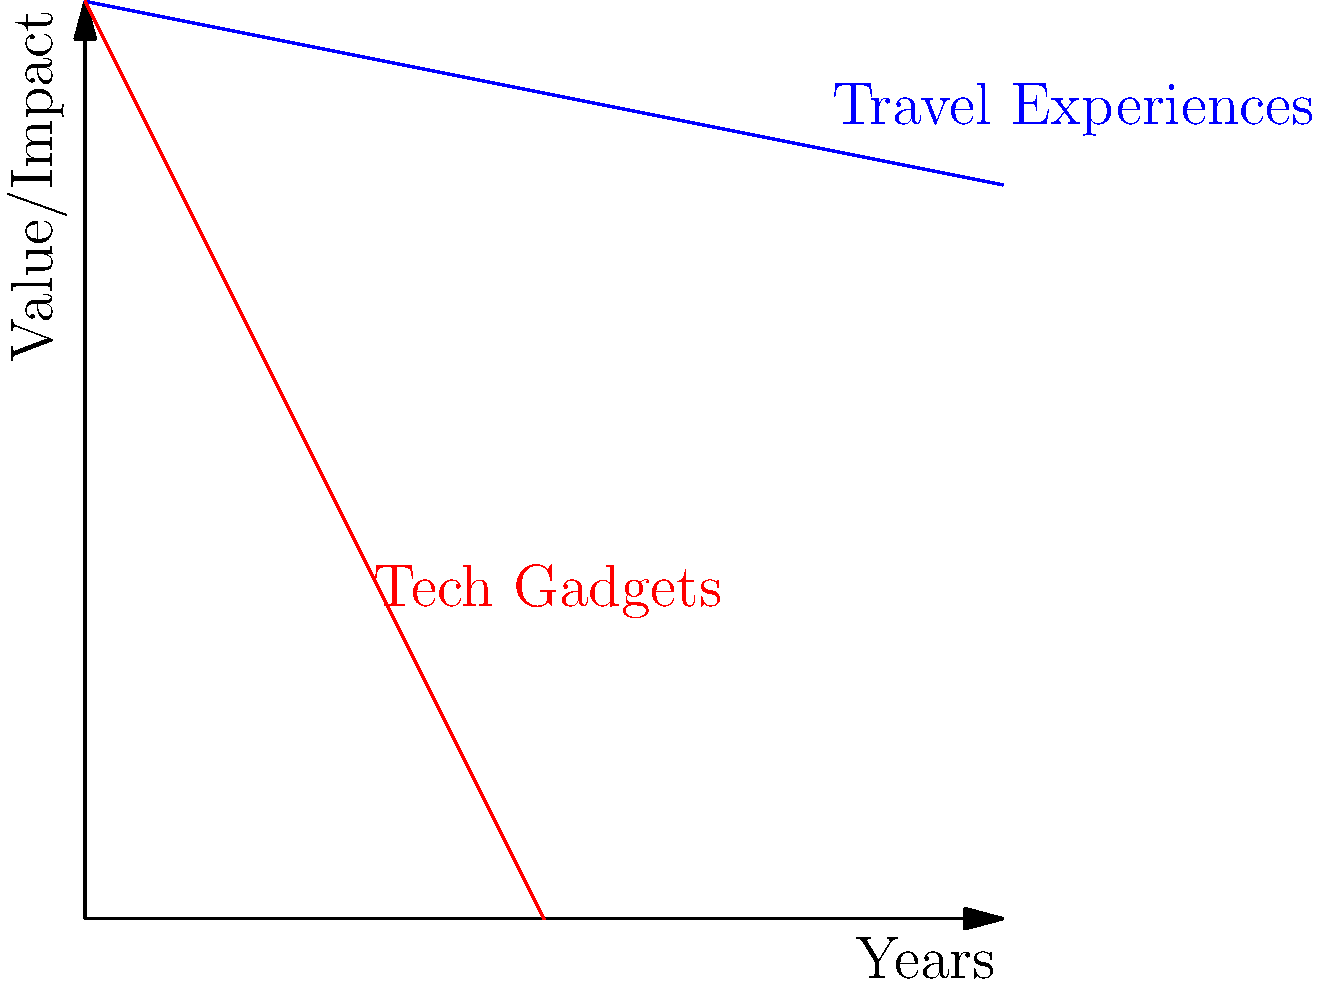Based on the graph comparing the lasting impact of travel experiences to the depreciation of tech gadgets over time, after how many years does the value of a tech gadget drop to half of its initial value, and what is the approximate percentage of impact retained for travel experiences at that same point in time? To solve this question, let's follow these steps:

1. Identify the initial value for both travel experiences and tech gadgets:
   Both start at a value of 10 on the y-axis.

2. Find when tech gadgets drop to half their value:
   - Initial value = 10
   - Half value = 5
   - The red line (tech gadgets) reaches y = 5 when x = 2.5 years

3. Calculate the value of travel experiences at 2.5 years:
   - The blue line (travel experiences) decreases more slowly
   - At x = 2.5 years, the y-value is approximately 9.5

4. Calculate the percentage of impact retained for travel experiences:
   - Initial value = 10
   - Value at 2.5 years ≈ 9.5
   - Percentage retained = (9.5 / 10) * 100 ≈ 95%

Therefore, tech gadgets lose half their value after 2.5 years, while travel experiences retain approximately 95% of their impact at the same point in time.
Answer: 2.5 years; 95% 